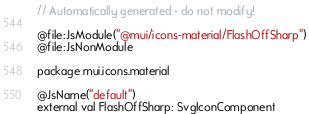<code> <loc_0><loc_0><loc_500><loc_500><_Kotlin_>// Automatically generated - do not modify!

@file:JsModule("@mui/icons-material/FlashOffSharp")
@file:JsNonModule

package mui.icons.material

@JsName("default")
external val FlashOffSharp: SvgIconComponent
</code> 